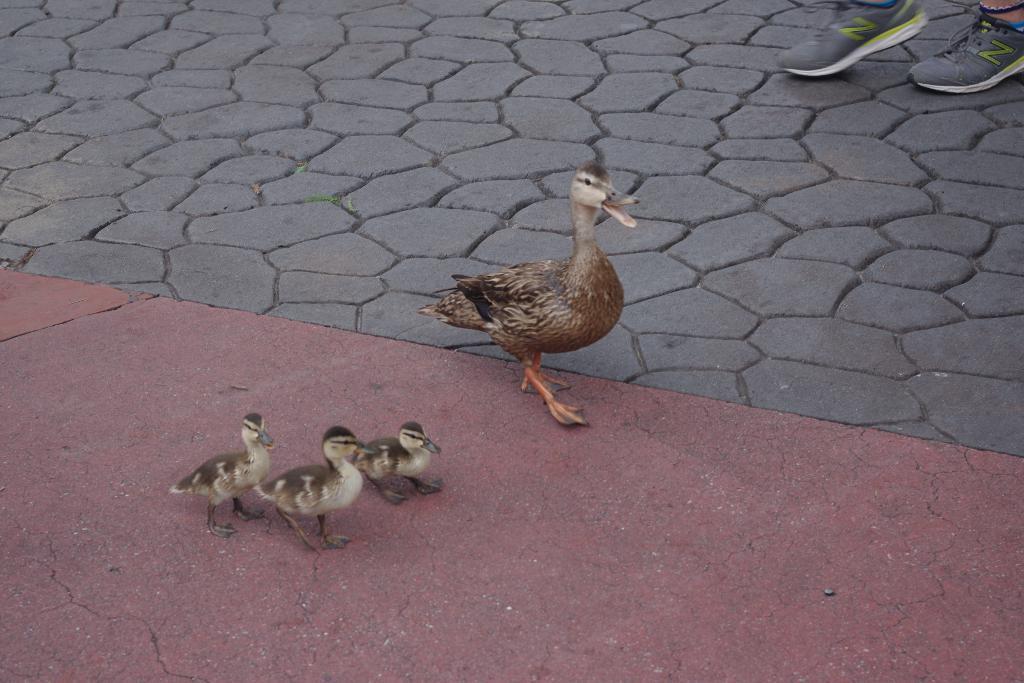Describe this image in one or two sentences. There are 4 ducks. There are legs of a person at the right back wearing shoes. 